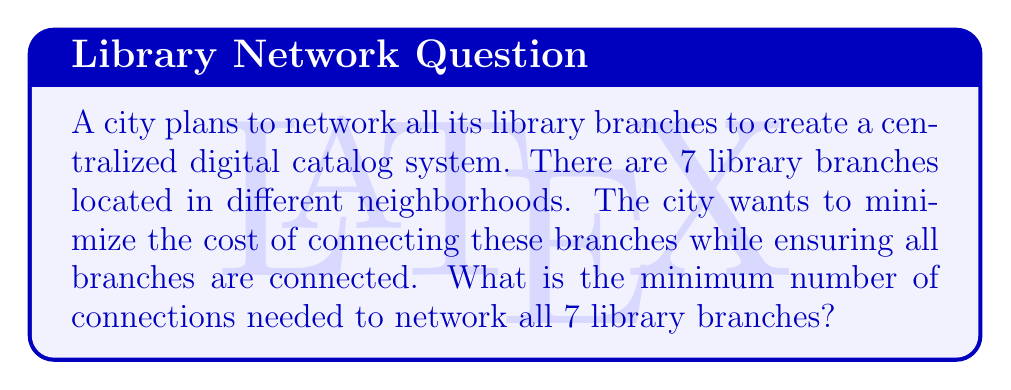Help me with this question. This problem can be solved using concepts from graph theory, specifically the properties of a minimum spanning tree.

1. Each library branch can be considered a vertex in a graph.
2. The connections between branches are the edges of the graph.
3. We need to find the minimum number of edges that connect all vertices without creating any cycles. This is the definition of a minimum spanning tree.

For a graph with $n$ vertices, the number of edges in a minimum spanning tree is always $n - 1$. This is because:

a) A tree by definition has no cycles.
b) To connect $n$ vertices without cycles, we need exactly $n - 1$ edges.
c) Adding one more edge would create a cycle, and removing any edge would disconnect the graph.

In this case:
* Number of library branches (vertices) = 7
* Minimum number of connections (edges) = $n - 1 = 7 - 1 = 6$

Therefore, the minimum number of connections needed to network all 7 library branches is 6.

This solution ensures that:
1. All branches are connected (either directly or indirectly).
2. There are no redundant connections (which would increase cost).
3. The network is resilient, as removing any single connection won't disconnect the entire system.
Answer: 6 connections 